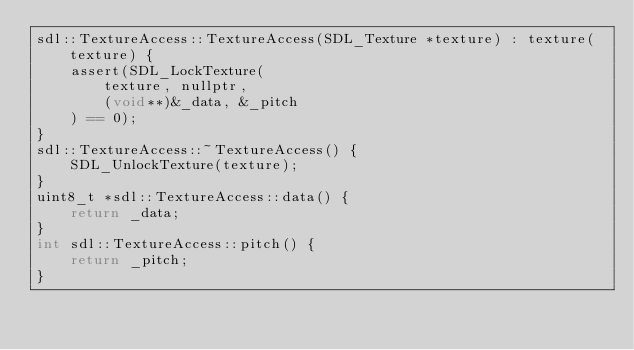Convert code to text. <code><loc_0><loc_0><loc_500><loc_500><_C++_>sdl::TextureAccess::TextureAccess(SDL_Texture *texture) : texture(texture) {
    assert(SDL_LockTexture(
        texture, nullptr,
        (void**)&_data, &_pitch
    ) == 0);
}
sdl::TextureAccess::~TextureAccess() {
    SDL_UnlockTexture(texture);
}
uint8_t *sdl::TextureAccess::data() {
    return _data;
}
int sdl::TextureAccess::pitch() {
    return _pitch;
}
</code> 